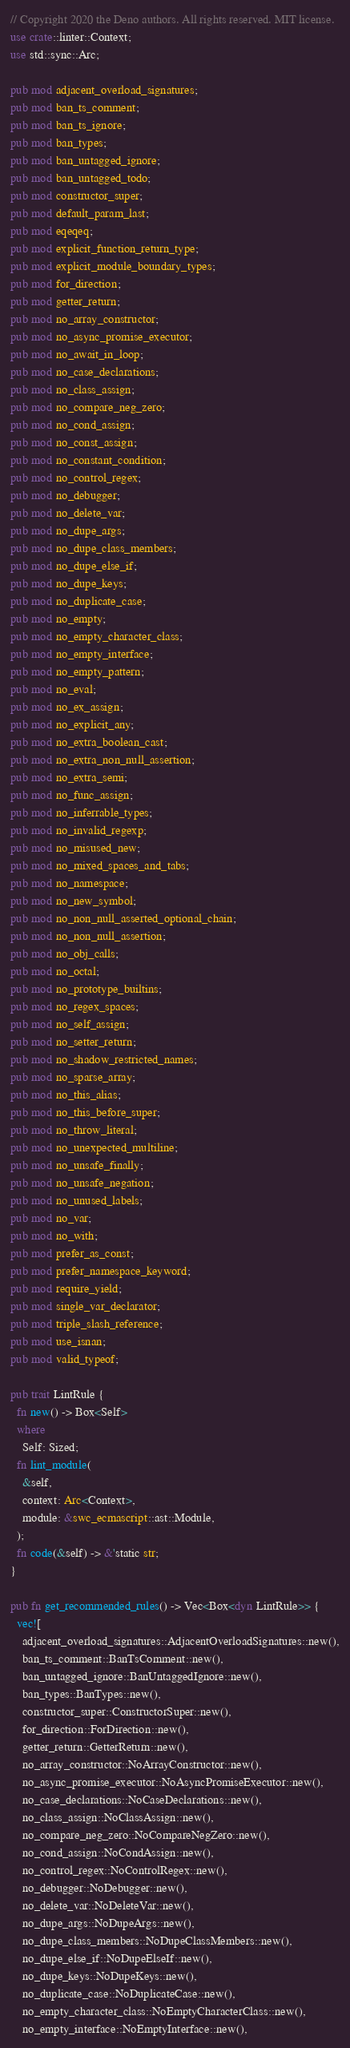Convert code to text. <code><loc_0><loc_0><loc_500><loc_500><_Rust_>// Copyright 2020 the Deno authors. All rights reserved. MIT license.
use crate::linter::Context;
use std::sync::Arc;

pub mod adjacent_overload_signatures;
pub mod ban_ts_comment;
pub mod ban_ts_ignore;
pub mod ban_types;
pub mod ban_untagged_ignore;
pub mod ban_untagged_todo;
pub mod constructor_super;
pub mod default_param_last;
pub mod eqeqeq;
pub mod explicit_function_return_type;
pub mod explicit_module_boundary_types;
pub mod for_direction;
pub mod getter_return;
pub mod no_array_constructor;
pub mod no_async_promise_executor;
pub mod no_await_in_loop;
pub mod no_case_declarations;
pub mod no_class_assign;
pub mod no_compare_neg_zero;
pub mod no_cond_assign;
pub mod no_const_assign;
pub mod no_constant_condition;
pub mod no_control_regex;
pub mod no_debugger;
pub mod no_delete_var;
pub mod no_dupe_args;
pub mod no_dupe_class_members;
pub mod no_dupe_else_if;
pub mod no_dupe_keys;
pub mod no_duplicate_case;
pub mod no_empty;
pub mod no_empty_character_class;
pub mod no_empty_interface;
pub mod no_empty_pattern;
pub mod no_eval;
pub mod no_ex_assign;
pub mod no_explicit_any;
pub mod no_extra_boolean_cast;
pub mod no_extra_non_null_assertion;
pub mod no_extra_semi;
pub mod no_func_assign;
pub mod no_inferrable_types;
pub mod no_invalid_regexp;
pub mod no_misused_new;
pub mod no_mixed_spaces_and_tabs;
pub mod no_namespace;
pub mod no_new_symbol;
pub mod no_non_null_asserted_optional_chain;
pub mod no_non_null_assertion;
pub mod no_obj_calls;
pub mod no_octal;
pub mod no_prototype_builtins;
pub mod no_regex_spaces;
pub mod no_self_assign;
pub mod no_setter_return;
pub mod no_shadow_restricted_names;
pub mod no_sparse_array;
pub mod no_this_alias;
pub mod no_this_before_super;
pub mod no_throw_literal;
pub mod no_unexpected_multiline;
pub mod no_unsafe_finally;
pub mod no_unsafe_negation;
pub mod no_unused_labels;
pub mod no_var;
pub mod no_with;
pub mod prefer_as_const;
pub mod prefer_namespace_keyword;
pub mod require_yield;
pub mod single_var_declarator;
pub mod triple_slash_reference;
pub mod use_isnan;
pub mod valid_typeof;

pub trait LintRule {
  fn new() -> Box<Self>
  where
    Self: Sized;
  fn lint_module(
    &self,
    context: Arc<Context>,
    module: &swc_ecmascript::ast::Module,
  );
  fn code(&self) -> &'static str;
}

pub fn get_recommended_rules() -> Vec<Box<dyn LintRule>> {
  vec![
    adjacent_overload_signatures::AdjacentOverloadSignatures::new(),
    ban_ts_comment::BanTsComment::new(),
    ban_untagged_ignore::BanUntaggedIgnore::new(),
    ban_types::BanTypes::new(),
    constructor_super::ConstructorSuper::new(),
    for_direction::ForDirection::new(),
    getter_return::GetterReturn::new(),
    no_array_constructor::NoArrayConstructor::new(),
    no_async_promise_executor::NoAsyncPromiseExecutor::new(),
    no_case_declarations::NoCaseDeclarations::new(),
    no_class_assign::NoClassAssign::new(),
    no_compare_neg_zero::NoCompareNegZero::new(),
    no_cond_assign::NoCondAssign::new(),
    no_control_regex::NoControlRegex::new(),
    no_debugger::NoDebugger::new(),
    no_delete_var::NoDeleteVar::new(),
    no_dupe_args::NoDupeArgs::new(),
    no_dupe_class_members::NoDupeClassMembers::new(),
    no_dupe_else_if::NoDupeElseIf::new(),
    no_dupe_keys::NoDupeKeys::new(),
    no_duplicate_case::NoDuplicateCase::new(),
    no_empty_character_class::NoEmptyCharacterClass::new(),
    no_empty_interface::NoEmptyInterface::new(),</code> 